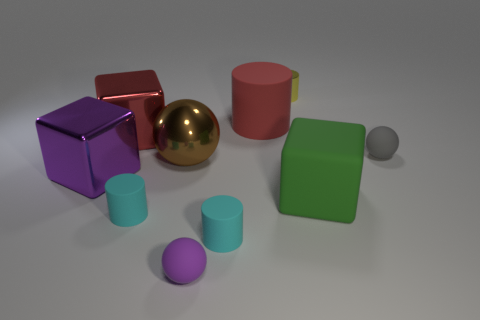There is a green block that is the same size as the red matte thing; what is its material?
Make the answer very short. Rubber. There is a sphere that is on the left side of the big red matte cylinder and behind the purple metallic thing; what is its material?
Provide a short and direct response. Metal. Is there a large brown metallic sphere?
Your response must be concise. Yes. There is a small metal cylinder; is it the same color as the small rubber cylinder that is left of the small purple ball?
Provide a short and direct response. No. What is the material of the big thing that is the same color as the large cylinder?
Ensure brevity in your answer.  Metal. Is there any other thing that is the same shape as the red rubber object?
Your response must be concise. Yes. What is the shape of the large red object that is to the right of the red object that is left of the small cyan matte cylinder to the right of the large brown thing?
Offer a very short reply. Cylinder. There is a big red shiny object; what shape is it?
Your answer should be compact. Cube. The metal block to the left of the red shiny object is what color?
Provide a succinct answer. Purple. There is a red thing that is to the right of the brown metallic object; is it the same size as the green object?
Give a very brief answer. Yes. 